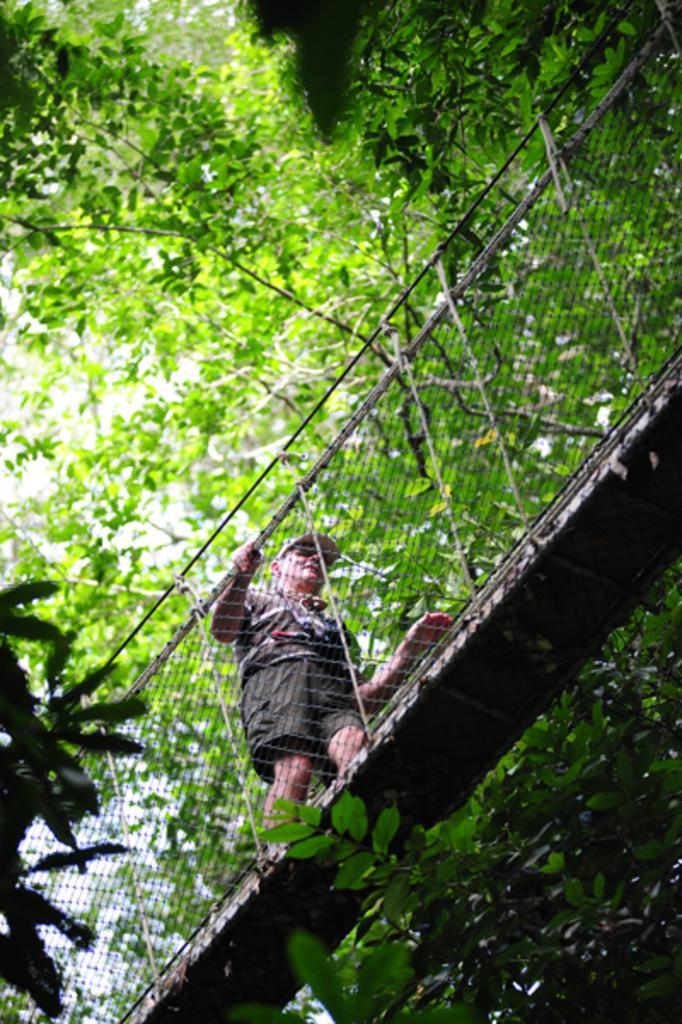Can you describe this image briefly? In this picture there is a man walking on bridge and we can see fence, trees and leaves. 